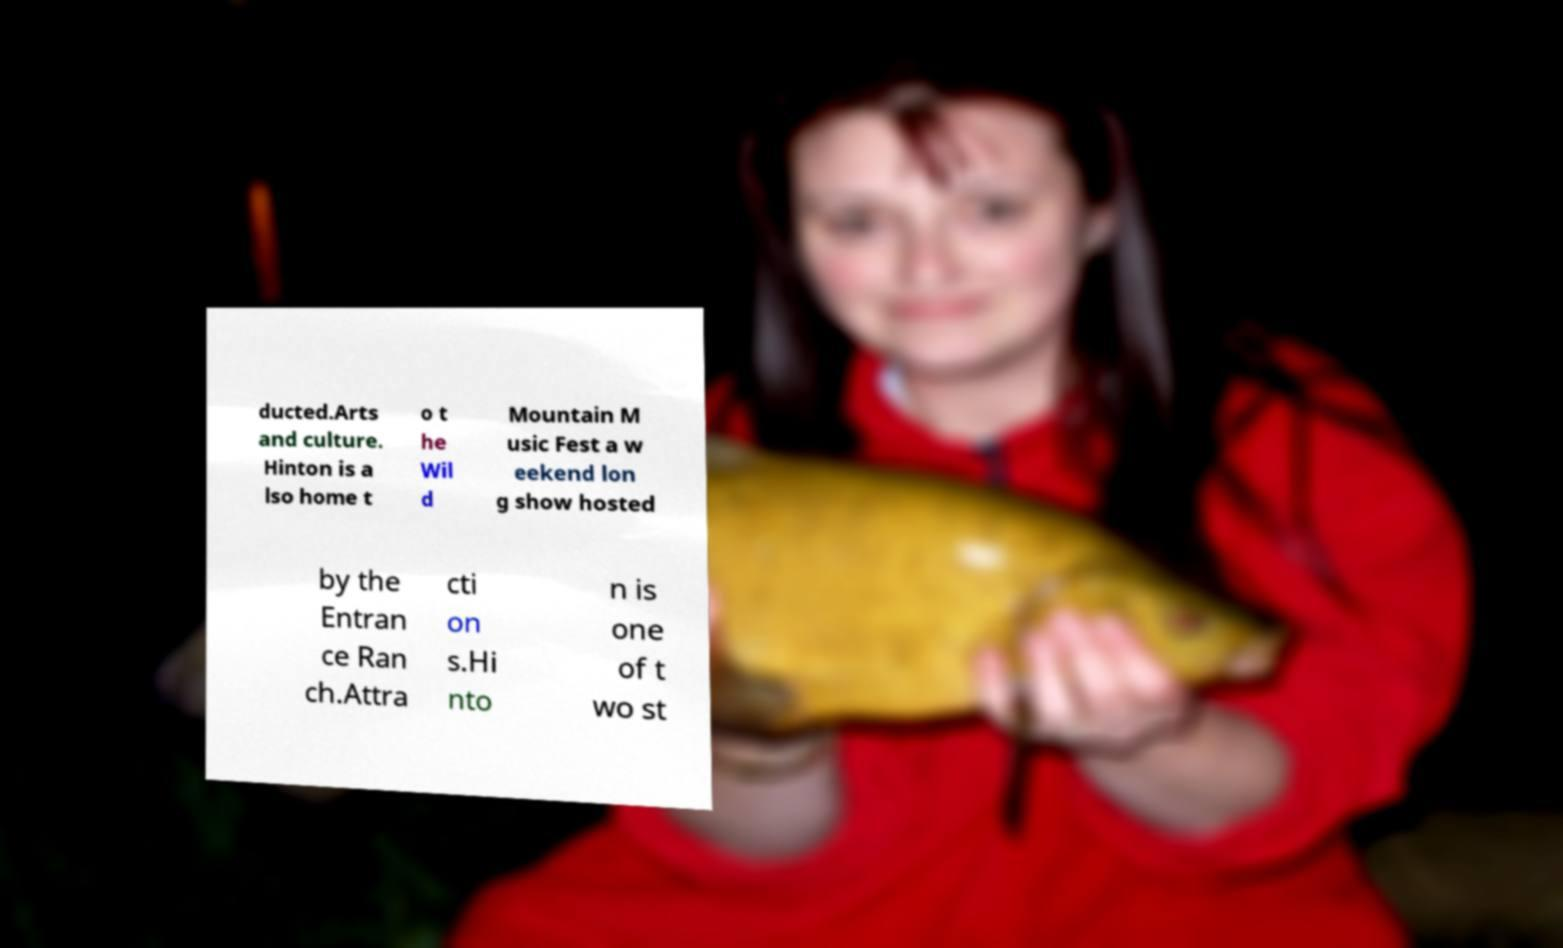What messages or text are displayed in this image? I need them in a readable, typed format. ducted.Arts and culture. Hinton is a lso home t o t he Wil d Mountain M usic Fest a w eekend lon g show hosted by the Entran ce Ran ch.Attra cti on s.Hi nto n is one of t wo st 